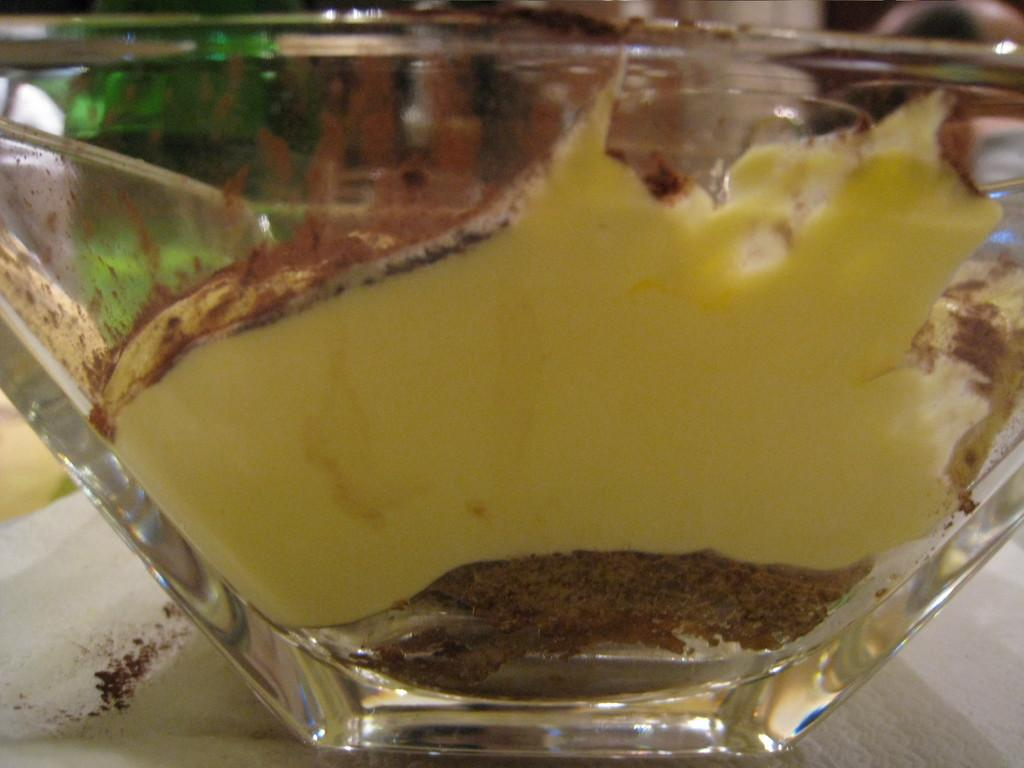What is in the bowl that is visible in the image? There is food in the bowl in the image. Can you describe the background of the image? The background of the image is blurry. What decision does the food make in the image? The food does not make any decisions in the image, as it is an inanimate object. 